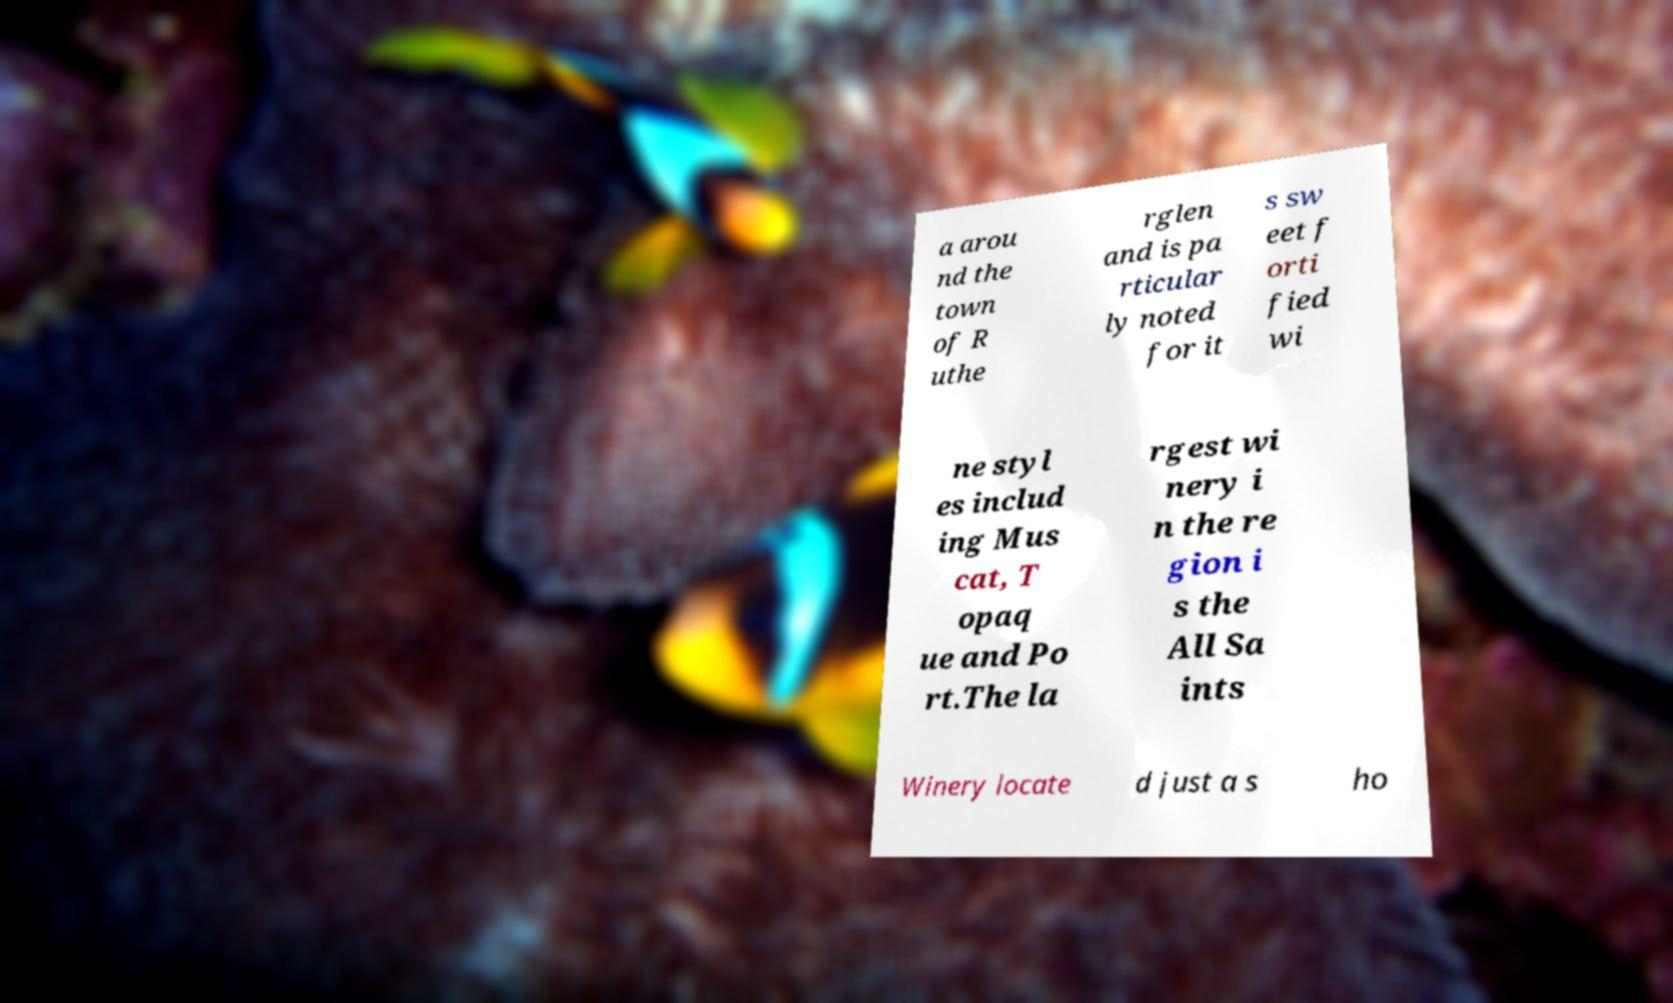Can you read and provide the text displayed in the image?This photo seems to have some interesting text. Can you extract and type it out for me? a arou nd the town of R uthe rglen and is pa rticular ly noted for it s sw eet f orti fied wi ne styl es includ ing Mus cat, T opaq ue and Po rt.The la rgest wi nery i n the re gion i s the All Sa ints Winery locate d just a s ho 